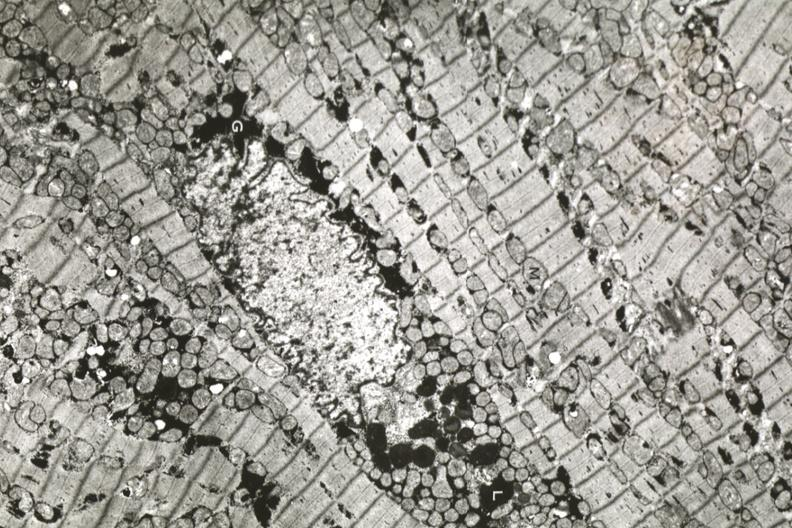where is this area in the body?
Answer the question using a single word or phrase. Heart 